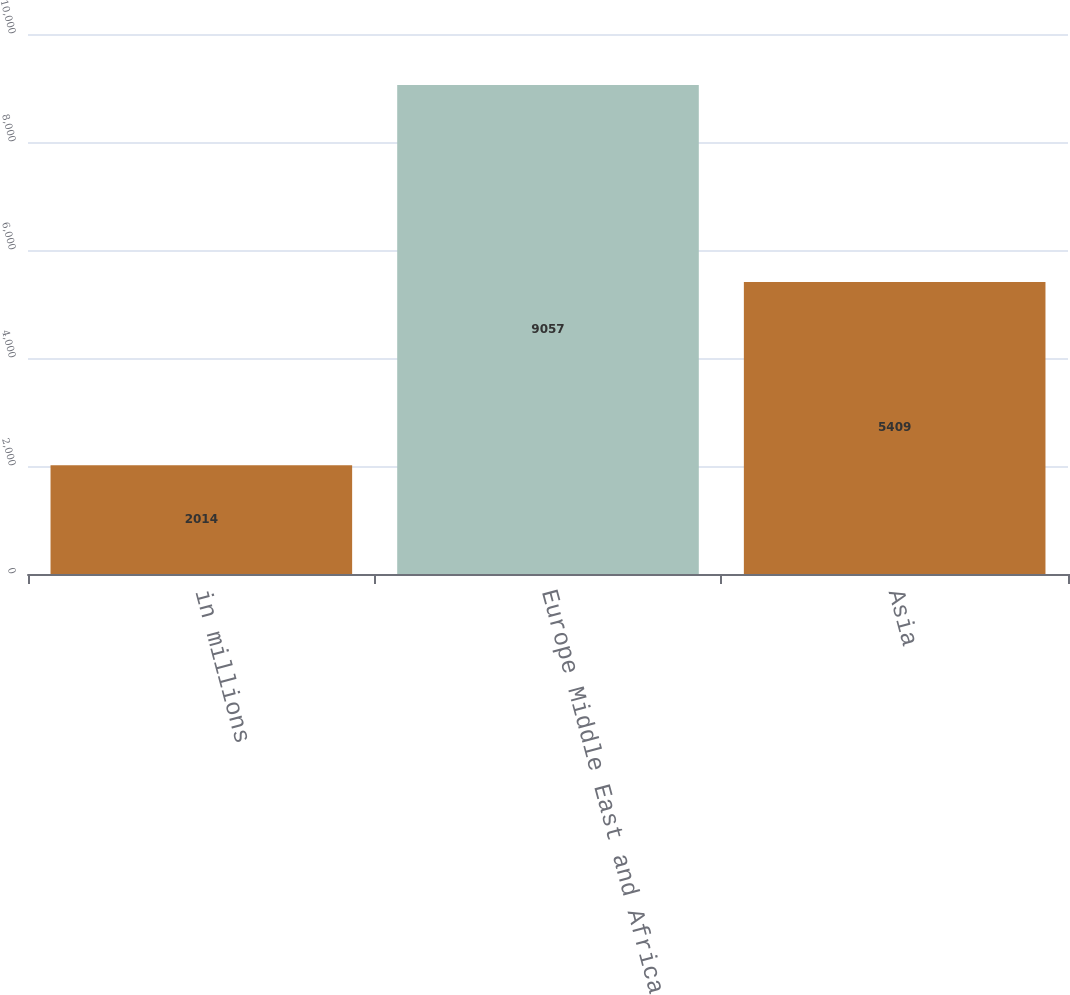Convert chart to OTSL. <chart><loc_0><loc_0><loc_500><loc_500><bar_chart><fcel>in millions<fcel>Europe Middle East and Africa<fcel>Asia<nl><fcel>2014<fcel>9057<fcel>5409<nl></chart> 